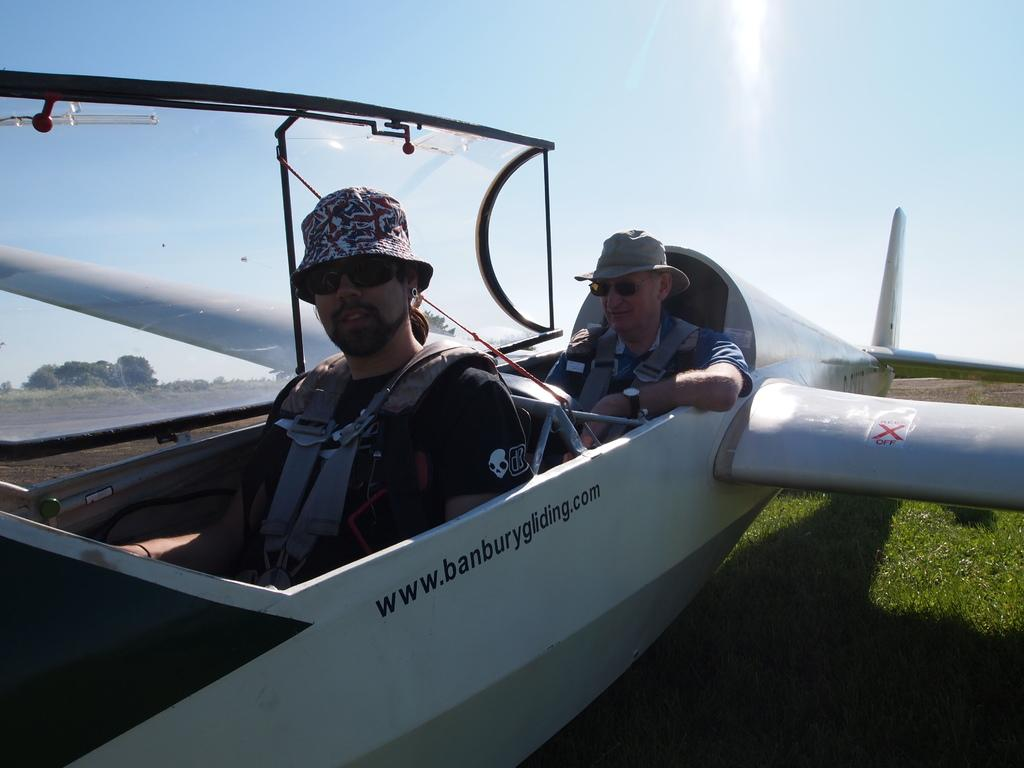How many people are in the image? There are two men in the image. What are the men doing in the image? The men are sitting in an airplane. What are the men wearing on their heads? The men are wearing hats. What type of natural environment can be seen in the image? There is grass visible in the image, and trees are in the background. What is visible in the sky in the image? The sky is visible in the background of the image. What type of cord is being used by the men to make a statement in the image? There is no cord or statement being made by the men in the image; they are simply sitting in an airplane. 